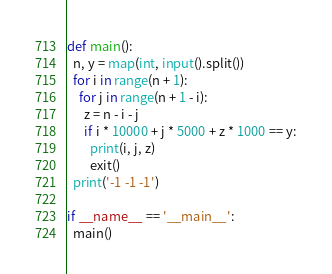Convert code to text. <code><loc_0><loc_0><loc_500><loc_500><_Python_>def main():
  n, y = map(int, input().split())
  for i in range(n + 1):
    for j in range(n + 1 - i):
      z = n - i - j
      if i * 10000 + j * 5000 + z * 1000 == y:
        print(i, j, z)
        exit()
  print('-1 -1 -1')
  
if __name__ == '__main__':
  main()</code> 